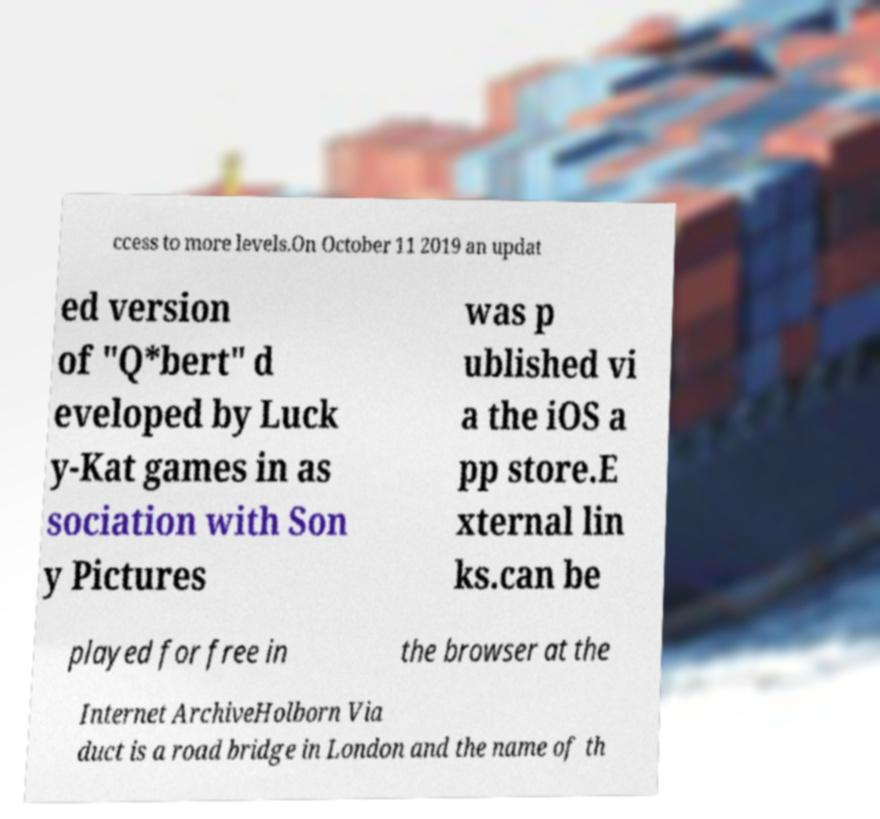Please read and relay the text visible in this image. What does it say? ccess to more levels.On October 11 2019 an updat ed version of "Q*bert" d eveloped by Luck y-Kat games in as sociation with Son y Pictures was p ublished vi a the iOS a pp store.E xternal lin ks.can be played for free in the browser at the Internet ArchiveHolborn Via duct is a road bridge in London and the name of th 